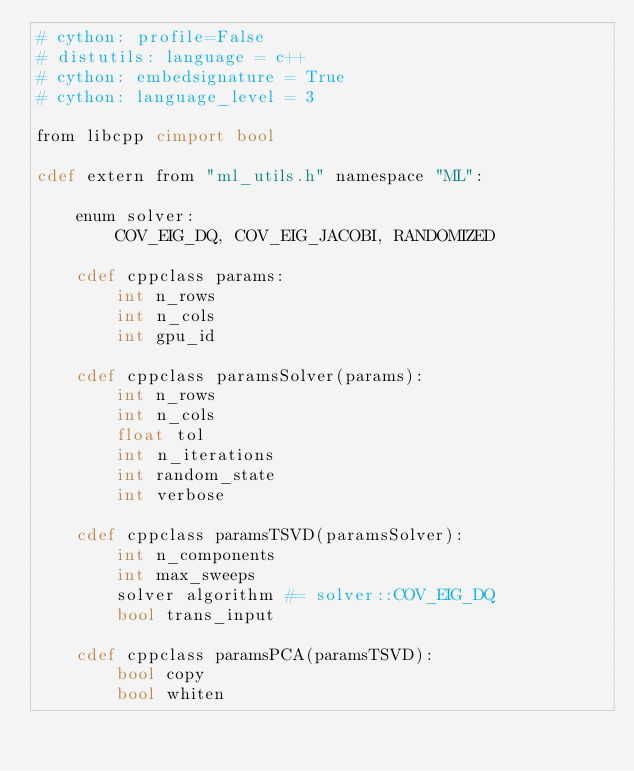<code> <loc_0><loc_0><loc_500><loc_500><_Cython_># cython: profile=False
# distutils: language = c++
# cython: embedsignature = True
# cython: language_level = 3

from libcpp cimport bool

cdef extern from "ml_utils.h" namespace "ML":

    enum solver:
        COV_EIG_DQ, COV_EIG_JACOBI, RANDOMIZED

    cdef cppclass params:
        int n_rows
        int n_cols
        int gpu_id

    cdef cppclass paramsSolver(params):
        int n_rows
        int n_cols
        float tol
        int n_iterations
        int random_state
        int verbose

    cdef cppclass paramsTSVD(paramsSolver):
        int n_components
        int max_sweeps
        solver algorithm #= solver::COV_EIG_DQ
        bool trans_input

    cdef cppclass paramsPCA(paramsTSVD):
        bool copy
        bool whiten
</code> 